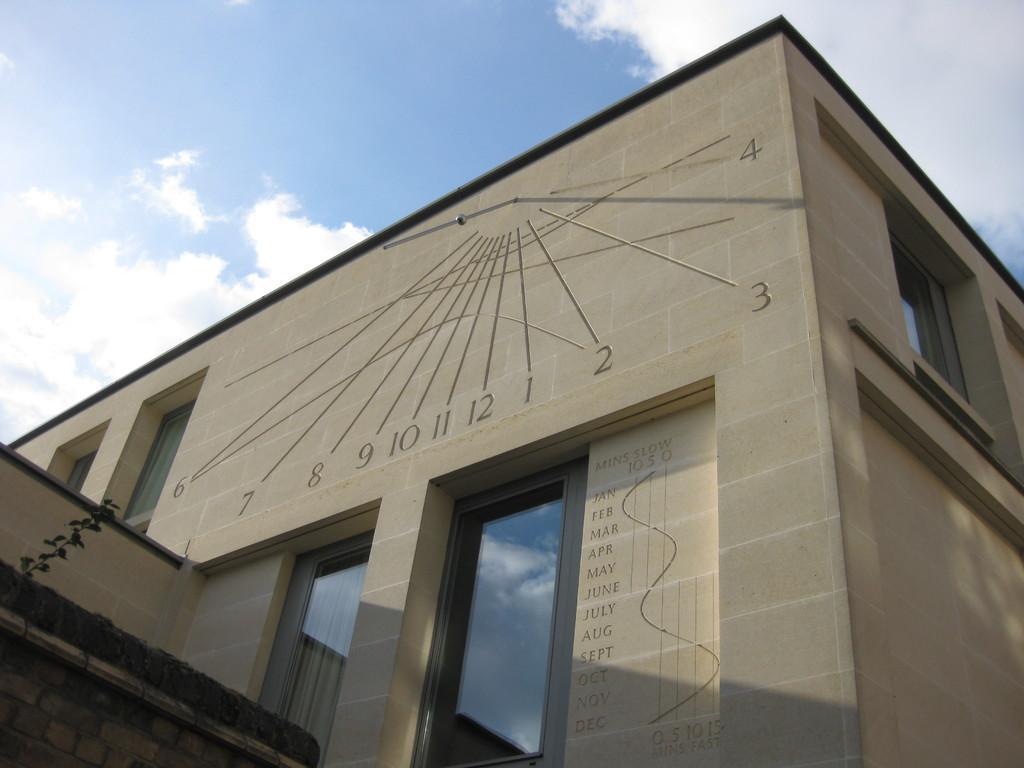Could you give a brief overview of what you see in this image? In this picture I can see a building and I can see text on the wall and I can see a plant on the left side and I can see blue cloudy sky and I can see reflection of blue cloudy sky on the glass. 